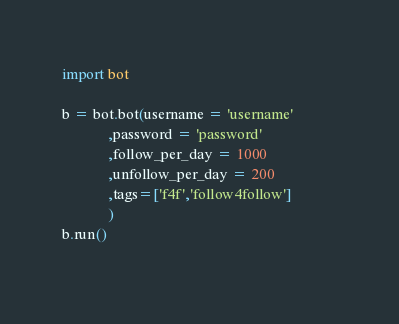<code> <loc_0><loc_0><loc_500><loc_500><_Python_>import bot

b = bot.bot(username = 'username'
            ,password = 'password'
            ,follow_per_day = 1000
            ,unfollow_per_day = 200
            ,tags=['f4f','follow4follow']            
            )
b.run()
       </code> 